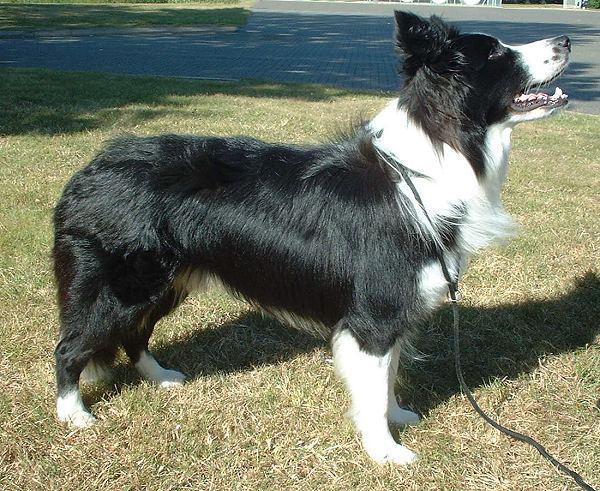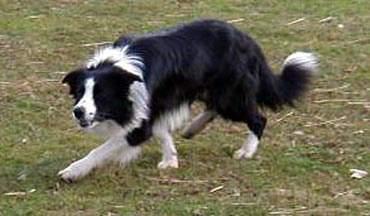The first image is the image on the left, the second image is the image on the right. Examine the images to the left and right. Is the description "There are two dogs in total." accurate? Answer yes or no. Yes. The first image is the image on the left, the second image is the image on the right. Given the left and right images, does the statement "The dog on the left has a leash around its neck." hold true? Answer yes or no. Yes. 